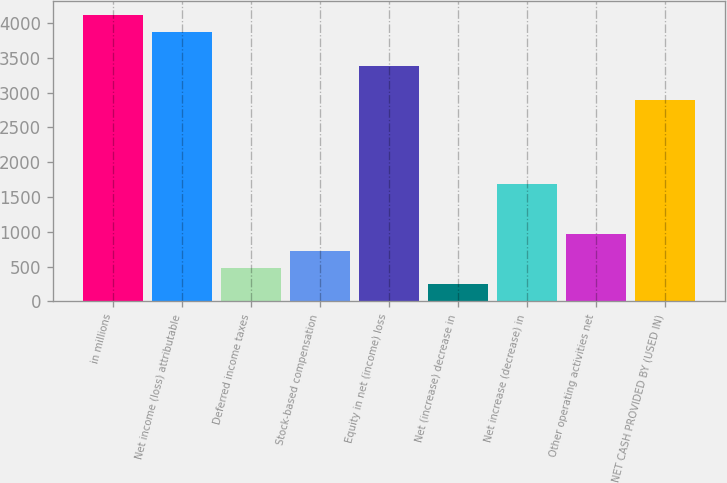Convert chart to OTSL. <chart><loc_0><loc_0><loc_500><loc_500><bar_chart><fcel>in millions<fcel>Net income (loss) attributable<fcel>Deferred income taxes<fcel>Stock-based compensation<fcel>Equity in net (income) loss<fcel>Net (increase) decrease in<fcel>Net increase (decrease) in<fcel>Other operating activities net<fcel>NET CASH PROVIDED BY (USED IN)<nl><fcel>4109.2<fcel>3867.6<fcel>485.2<fcel>726.8<fcel>3384.4<fcel>243.6<fcel>1693.2<fcel>968.4<fcel>2901.2<nl></chart> 